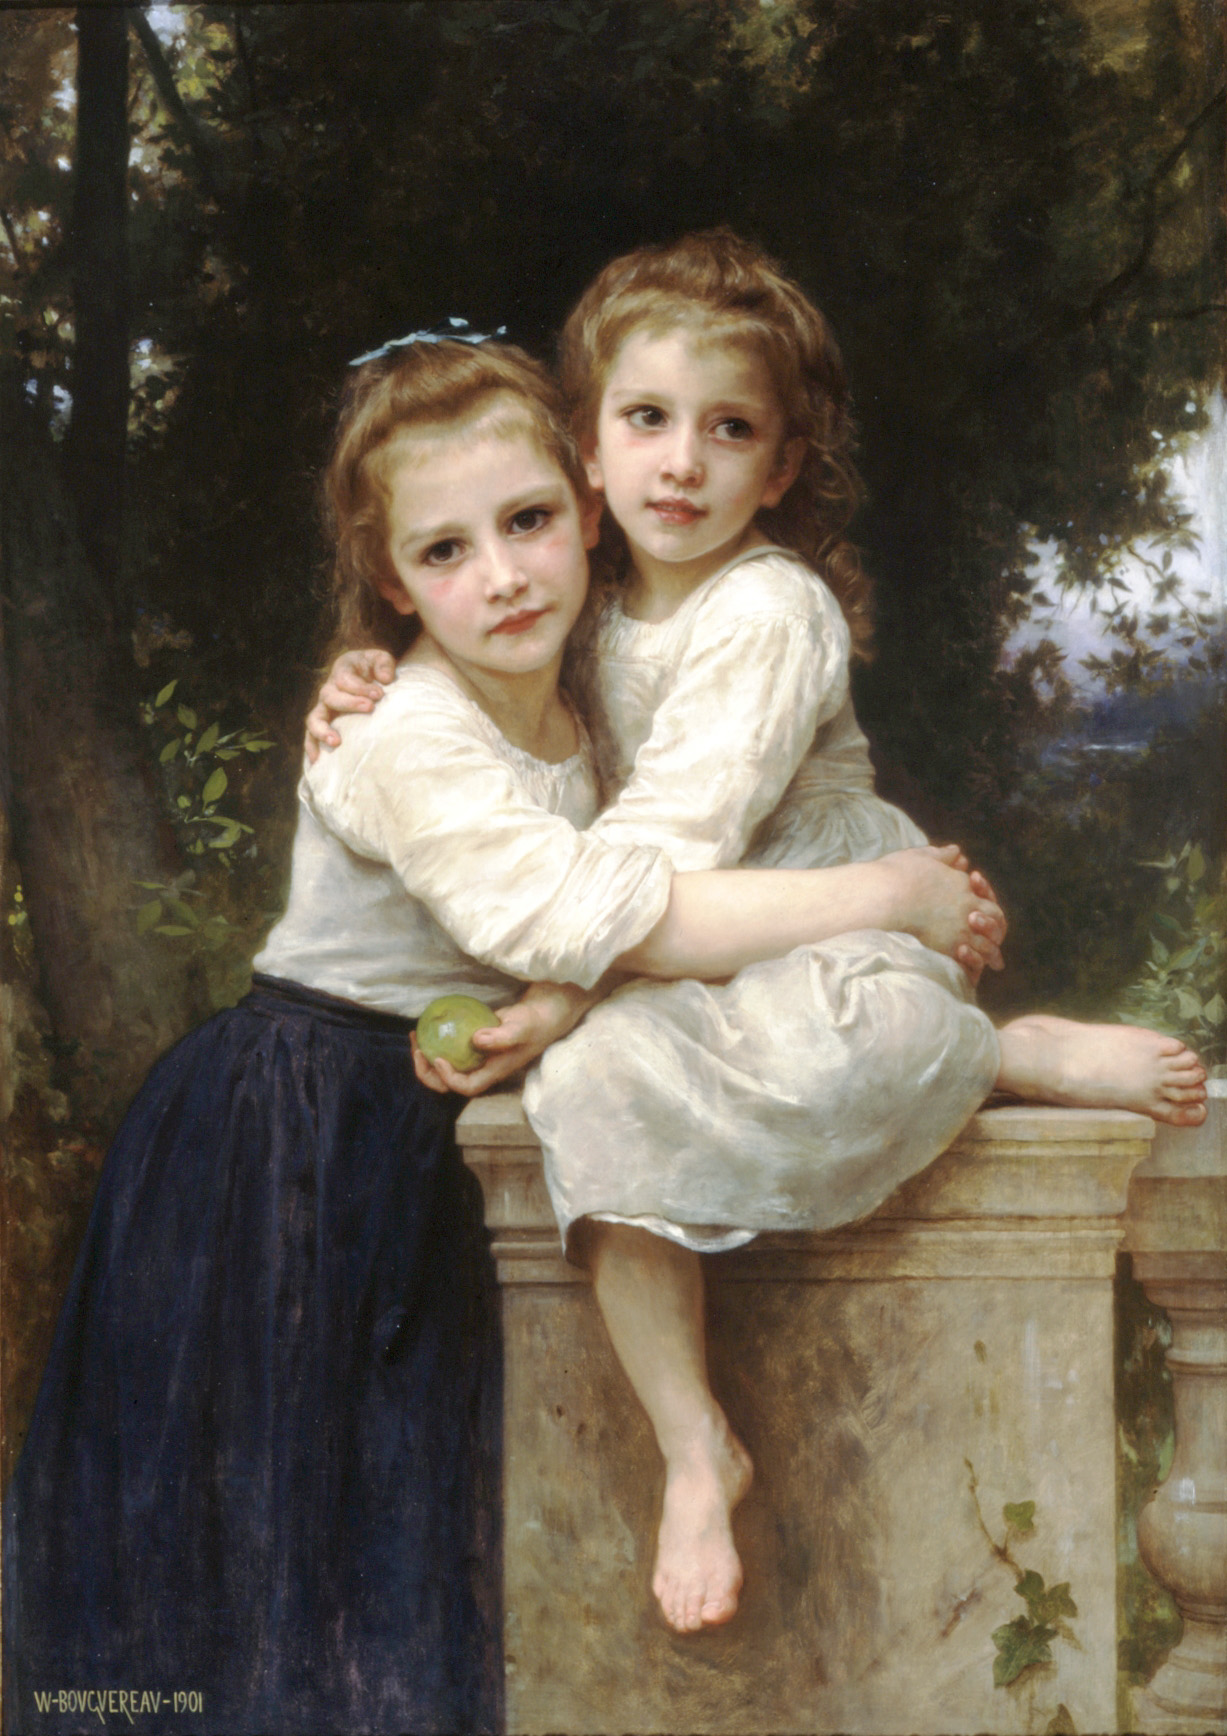What emotions do you think are conveyed in this painting? The painting conveys a deep sense of warmth and tenderness through the embrace of the two young girls. Their expressions suggest a mix of contentment and perhaps a touch of melancholy, evoking a longing for simpler, more innocent times. The serene garden setting enhances these emotions, providing a backdrop that suggests peace and tranquility. The meticulous attention to detail and the realistic style further deepen the emotional impact, making the viewer feel intimately connected to the scene. Why do you think the artist chose to include the apple in one of the girl's hands? The inclusion of the apple in the girl’s hand could carry various symbolic meanings. Traditionally, apples have been associated with knowledge and temptation, referencing biblical stories such as Adam and Eve. In this context, it could symbolize innocence and the fleeting nature of childhood. Alternatively, it may simply be a detail that adds to the realism of the painting, enriching the scene with a natural, everyday element. The green color of the apple also adds a subtle complement to the lush garden background, enhancing the overall harmony of the composition. 